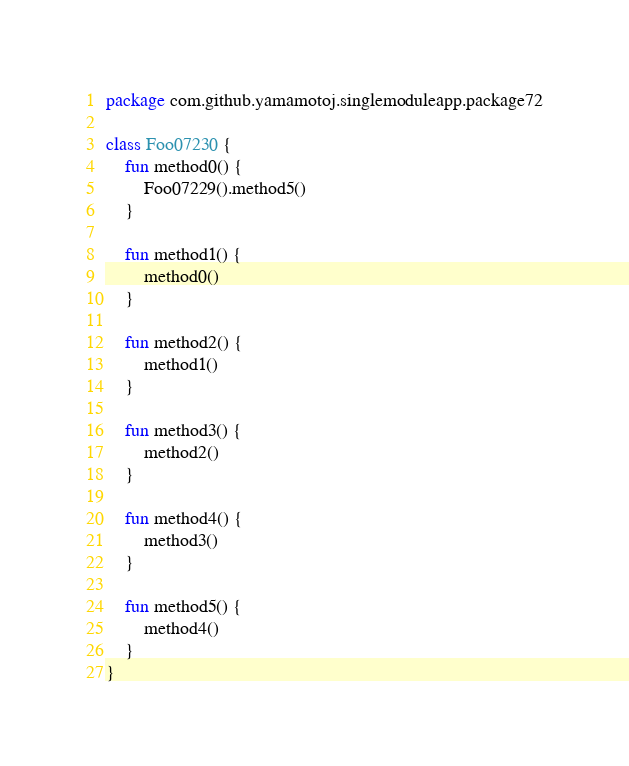<code> <loc_0><loc_0><loc_500><loc_500><_Kotlin_>package com.github.yamamotoj.singlemoduleapp.package72

class Foo07230 {
    fun method0() {
        Foo07229().method5()
    }

    fun method1() {
        method0()
    }

    fun method2() {
        method1()
    }

    fun method3() {
        method2()
    }

    fun method4() {
        method3()
    }

    fun method5() {
        method4()
    }
}
</code> 